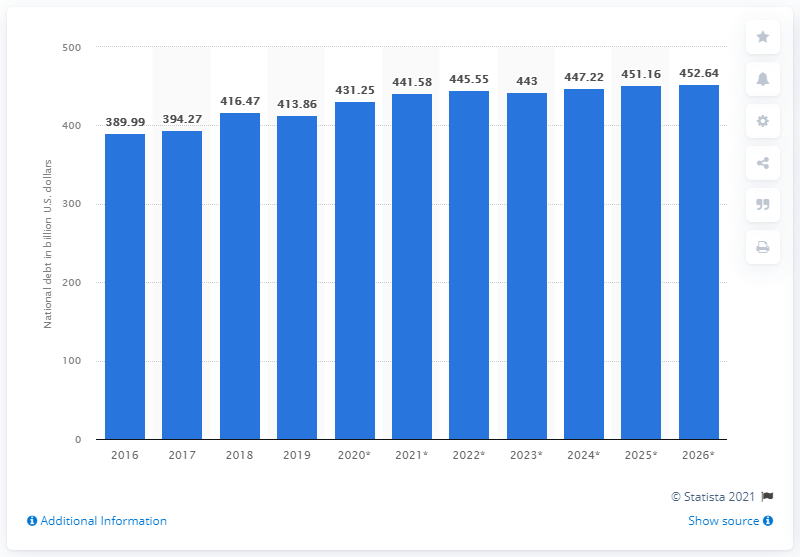List a handful of essential elements in this visual. In 2019, Greece's national debt was 413.86 billion dollars. 